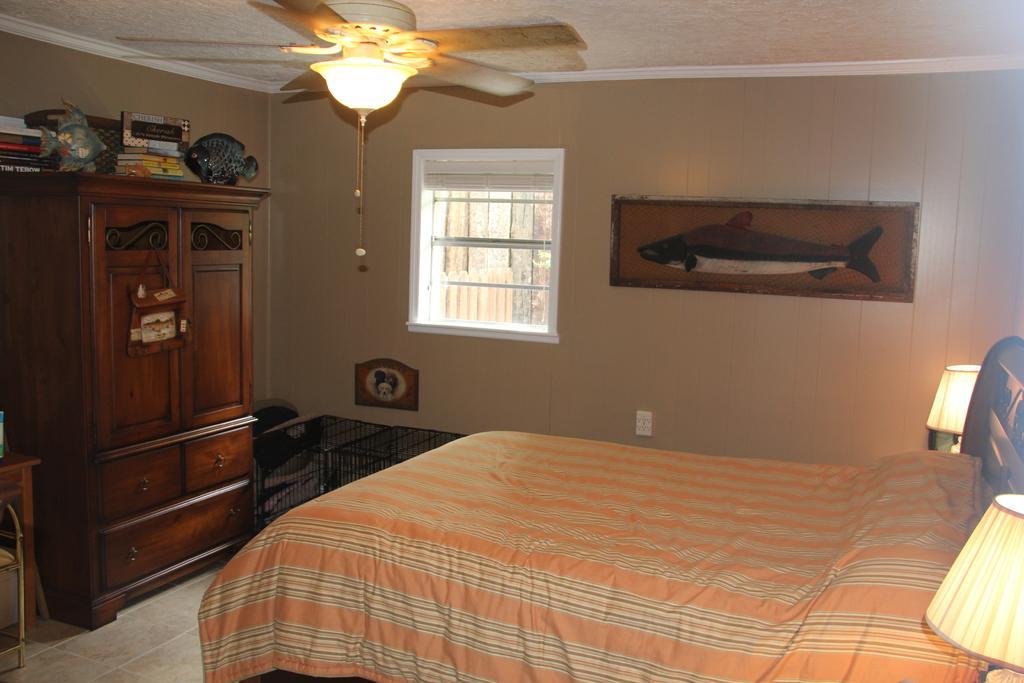In one or two sentences, can you explain what this image depicts? This image is clicked in a bedroom. To the right, there is a bed, beside that there is a bed lamp. In the background, there is a wall, on which a photo frame of shark and a window is there. To the left there is a cupboard on which some books are kept. At the top, there is a slab to which a fan is fixed. 